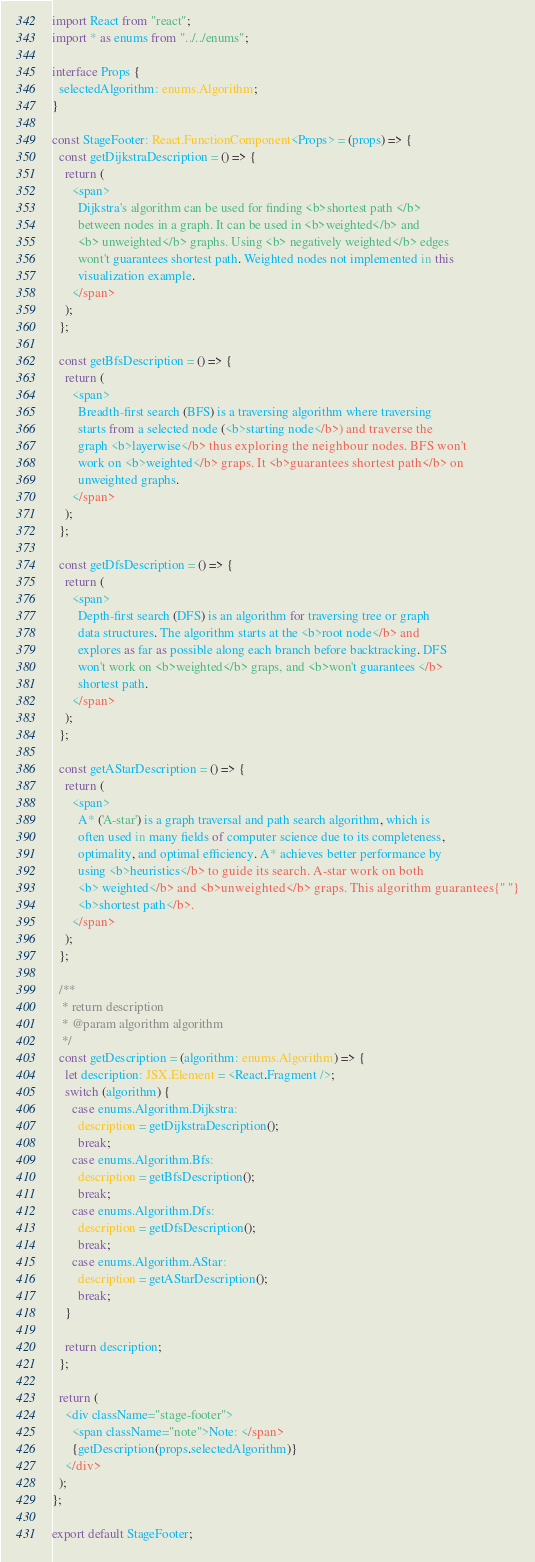Convert code to text. <code><loc_0><loc_0><loc_500><loc_500><_TypeScript_>import React from "react";
import * as enums from "../../enums";

interface Props {
  selectedAlgorithm: enums.Algorithm;
}

const StageFooter: React.FunctionComponent<Props> = (props) => {
  const getDijkstraDescription = () => {
    return (
      <span>
        Dijkstra's algorithm can be used for finding <b>shortest path </b>
        between nodes in a graph. It can be used in <b>weighted</b> and
        <b> unweighted</b> graphs. Using <b> negatively weighted</b> edges
        wont't guarantees shortest path. Weighted nodes not implemented in this
        visualization example.
      </span>
    );
  };

  const getBfsDescription = () => {
    return (
      <span>
        Breadth-first search (BFS) is a traversing algorithm where traversing
        starts from a selected node (<b>starting node</b>) and traverse the
        graph <b>layerwise</b> thus exploring the neighbour nodes. BFS won't
        work on <b>weighted</b> graps. It <b>guarantees shortest path</b> on
        unweighted graphs.
      </span>
    );
  };

  const getDfsDescription = () => {
    return (
      <span>
        Depth-first search (DFS) is an algorithm for traversing tree or graph
        data structures. The algorithm starts at the <b>root node</b> and
        explores as far as possible along each branch before backtracking. DFS
        won't work on <b>weighted</b> graps, and <b>won't guarantees </b>
        shortest path.
      </span>
    );
  };

  const getAStarDescription = () => {
    return (
      <span>
        A* ('A-star') is a graph traversal and path search algorithm, which is
        often used in many fields of computer science due to its completeness,
        optimality, and optimal efficiency. A* achieves better performance by
        using <b>heuristics</b> to guide its search. A-star work on both
        <b> weighted</b> and <b>unweighted</b> graps. This algorithm guarantees{" "}
        <b>shortest path</b>.
      </span>
    );
  };

  /**
   * return description
   * @param algorithm algorithm
   */
  const getDescription = (algorithm: enums.Algorithm) => {
    let description: JSX.Element = <React.Fragment />;
    switch (algorithm) {
      case enums.Algorithm.Dijkstra:
        description = getDijkstraDescription();
        break;
      case enums.Algorithm.Bfs:
        description = getBfsDescription();
        break;
      case enums.Algorithm.Dfs:
        description = getDfsDescription();
        break;
      case enums.Algorithm.AStar:
        description = getAStarDescription();
        break;
    }

    return description;
  };

  return (
    <div className="stage-footer">
      <span className="note">Note: </span>
      {getDescription(props.selectedAlgorithm)}
    </div>
  );
};

export default StageFooter;
</code> 